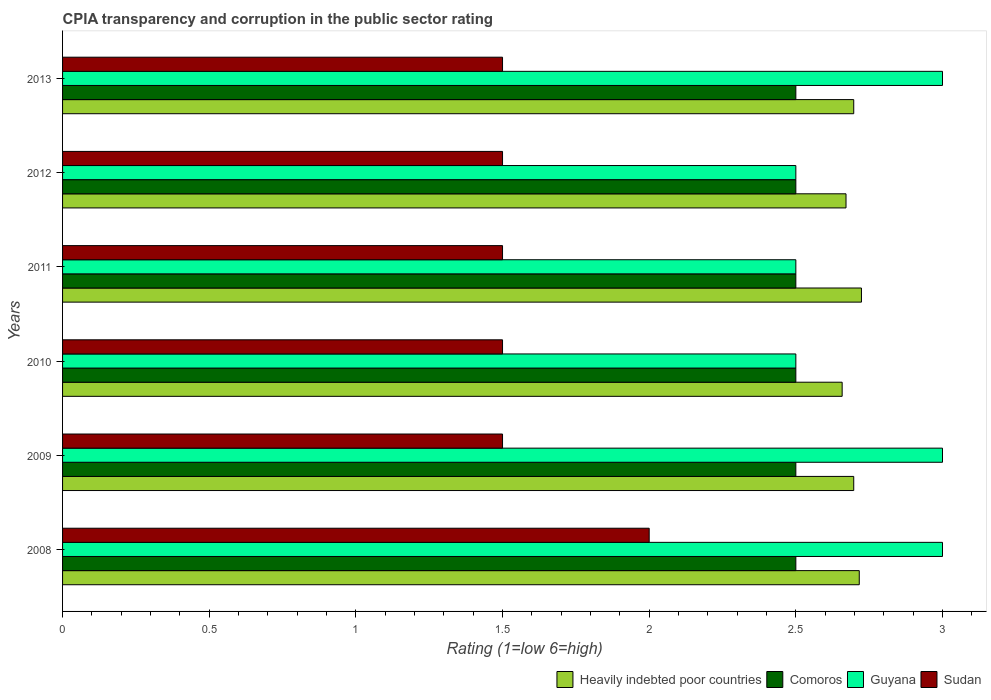How many different coloured bars are there?
Make the answer very short. 4. Are the number of bars per tick equal to the number of legend labels?
Your response must be concise. Yes. How many bars are there on the 5th tick from the top?
Keep it short and to the point. 4. What is the label of the 2nd group of bars from the top?
Make the answer very short. 2012. In how many cases, is the number of bars for a given year not equal to the number of legend labels?
Offer a very short reply. 0. Across all years, what is the minimum CPIA rating in Comoros?
Provide a short and direct response. 2.5. In which year was the CPIA rating in Comoros minimum?
Provide a short and direct response. 2008. What is the difference between the CPIA rating in Heavily indebted poor countries in 2009 and that in 2011?
Offer a very short reply. -0.03. What is the difference between the CPIA rating in Sudan in 2008 and the CPIA rating in Heavily indebted poor countries in 2013?
Offer a terse response. -0.7. In how many years, is the CPIA rating in Comoros greater than 1.8 ?
Provide a short and direct response. 6. What is the difference between the highest and the second highest CPIA rating in Heavily indebted poor countries?
Make the answer very short. 0.01. In how many years, is the CPIA rating in Heavily indebted poor countries greater than the average CPIA rating in Heavily indebted poor countries taken over all years?
Provide a short and direct response. 4. What does the 1st bar from the top in 2013 represents?
Provide a succinct answer. Sudan. What does the 2nd bar from the bottom in 2010 represents?
Make the answer very short. Comoros. Is it the case that in every year, the sum of the CPIA rating in Sudan and CPIA rating in Heavily indebted poor countries is greater than the CPIA rating in Comoros?
Provide a succinct answer. Yes. Are all the bars in the graph horizontal?
Give a very brief answer. Yes. How many years are there in the graph?
Provide a short and direct response. 6. Does the graph contain any zero values?
Provide a short and direct response. No. Does the graph contain grids?
Make the answer very short. No. Where does the legend appear in the graph?
Ensure brevity in your answer.  Bottom right. What is the title of the graph?
Offer a terse response. CPIA transparency and corruption in the public sector rating. Does "East Asia (developing only)" appear as one of the legend labels in the graph?
Your answer should be compact. No. What is the label or title of the X-axis?
Ensure brevity in your answer.  Rating (1=low 6=high). What is the Rating (1=low 6=high) of Heavily indebted poor countries in 2008?
Your response must be concise. 2.72. What is the Rating (1=low 6=high) in Heavily indebted poor countries in 2009?
Provide a short and direct response. 2.7. What is the Rating (1=low 6=high) of Comoros in 2009?
Offer a very short reply. 2.5. What is the Rating (1=low 6=high) of Guyana in 2009?
Your answer should be compact. 3. What is the Rating (1=low 6=high) in Heavily indebted poor countries in 2010?
Ensure brevity in your answer.  2.66. What is the Rating (1=low 6=high) of Comoros in 2010?
Provide a short and direct response. 2.5. What is the Rating (1=low 6=high) of Guyana in 2010?
Offer a terse response. 2.5. What is the Rating (1=low 6=high) in Sudan in 2010?
Give a very brief answer. 1.5. What is the Rating (1=low 6=high) of Heavily indebted poor countries in 2011?
Ensure brevity in your answer.  2.72. What is the Rating (1=low 6=high) in Guyana in 2011?
Give a very brief answer. 2.5. What is the Rating (1=low 6=high) in Sudan in 2011?
Your response must be concise. 1.5. What is the Rating (1=low 6=high) in Heavily indebted poor countries in 2012?
Offer a terse response. 2.67. What is the Rating (1=low 6=high) of Comoros in 2012?
Ensure brevity in your answer.  2.5. What is the Rating (1=low 6=high) of Heavily indebted poor countries in 2013?
Keep it short and to the point. 2.7. What is the Rating (1=low 6=high) of Guyana in 2013?
Provide a short and direct response. 3. What is the Rating (1=low 6=high) in Sudan in 2013?
Your answer should be very brief. 1.5. Across all years, what is the maximum Rating (1=low 6=high) in Heavily indebted poor countries?
Ensure brevity in your answer.  2.72. Across all years, what is the maximum Rating (1=low 6=high) of Comoros?
Offer a terse response. 2.5. Across all years, what is the minimum Rating (1=low 6=high) of Heavily indebted poor countries?
Provide a short and direct response. 2.66. Across all years, what is the minimum Rating (1=low 6=high) of Sudan?
Your response must be concise. 1.5. What is the total Rating (1=low 6=high) of Heavily indebted poor countries in the graph?
Your answer should be compact. 16.16. What is the total Rating (1=low 6=high) in Guyana in the graph?
Provide a succinct answer. 16.5. What is the total Rating (1=low 6=high) of Sudan in the graph?
Offer a terse response. 9.5. What is the difference between the Rating (1=low 6=high) in Heavily indebted poor countries in 2008 and that in 2009?
Your answer should be compact. 0.02. What is the difference between the Rating (1=low 6=high) of Comoros in 2008 and that in 2009?
Your answer should be very brief. 0. What is the difference between the Rating (1=low 6=high) in Guyana in 2008 and that in 2009?
Your answer should be very brief. 0. What is the difference between the Rating (1=low 6=high) in Heavily indebted poor countries in 2008 and that in 2010?
Provide a short and direct response. 0.06. What is the difference between the Rating (1=low 6=high) of Comoros in 2008 and that in 2010?
Your answer should be very brief. 0. What is the difference between the Rating (1=low 6=high) in Guyana in 2008 and that in 2010?
Your answer should be compact. 0.5. What is the difference between the Rating (1=low 6=high) in Heavily indebted poor countries in 2008 and that in 2011?
Provide a succinct answer. -0.01. What is the difference between the Rating (1=low 6=high) in Comoros in 2008 and that in 2011?
Make the answer very short. 0. What is the difference between the Rating (1=low 6=high) of Guyana in 2008 and that in 2011?
Provide a short and direct response. 0.5. What is the difference between the Rating (1=low 6=high) of Heavily indebted poor countries in 2008 and that in 2012?
Offer a very short reply. 0.05. What is the difference between the Rating (1=low 6=high) in Comoros in 2008 and that in 2012?
Offer a very short reply. 0. What is the difference between the Rating (1=low 6=high) of Guyana in 2008 and that in 2012?
Provide a succinct answer. 0.5. What is the difference between the Rating (1=low 6=high) of Heavily indebted poor countries in 2008 and that in 2013?
Make the answer very short. 0.02. What is the difference between the Rating (1=low 6=high) of Guyana in 2008 and that in 2013?
Give a very brief answer. 0. What is the difference between the Rating (1=low 6=high) in Sudan in 2008 and that in 2013?
Offer a very short reply. 0.5. What is the difference between the Rating (1=low 6=high) of Heavily indebted poor countries in 2009 and that in 2010?
Provide a succinct answer. 0.04. What is the difference between the Rating (1=low 6=high) in Heavily indebted poor countries in 2009 and that in 2011?
Offer a terse response. -0.03. What is the difference between the Rating (1=low 6=high) in Heavily indebted poor countries in 2009 and that in 2012?
Provide a succinct answer. 0.03. What is the difference between the Rating (1=low 6=high) in Guyana in 2009 and that in 2013?
Make the answer very short. 0. What is the difference between the Rating (1=low 6=high) of Heavily indebted poor countries in 2010 and that in 2011?
Your answer should be very brief. -0.07. What is the difference between the Rating (1=low 6=high) in Sudan in 2010 and that in 2011?
Your answer should be compact. 0. What is the difference between the Rating (1=low 6=high) in Heavily indebted poor countries in 2010 and that in 2012?
Provide a short and direct response. -0.01. What is the difference between the Rating (1=low 6=high) of Comoros in 2010 and that in 2012?
Your answer should be compact. 0. What is the difference between the Rating (1=low 6=high) in Guyana in 2010 and that in 2012?
Provide a short and direct response. 0. What is the difference between the Rating (1=low 6=high) of Heavily indebted poor countries in 2010 and that in 2013?
Make the answer very short. -0.04. What is the difference between the Rating (1=low 6=high) of Sudan in 2010 and that in 2013?
Keep it short and to the point. 0. What is the difference between the Rating (1=low 6=high) in Heavily indebted poor countries in 2011 and that in 2012?
Your answer should be very brief. 0.05. What is the difference between the Rating (1=low 6=high) of Guyana in 2011 and that in 2012?
Keep it short and to the point. 0. What is the difference between the Rating (1=low 6=high) of Heavily indebted poor countries in 2011 and that in 2013?
Give a very brief answer. 0.03. What is the difference between the Rating (1=low 6=high) of Heavily indebted poor countries in 2012 and that in 2013?
Keep it short and to the point. -0.03. What is the difference between the Rating (1=low 6=high) in Sudan in 2012 and that in 2013?
Give a very brief answer. 0. What is the difference between the Rating (1=low 6=high) of Heavily indebted poor countries in 2008 and the Rating (1=low 6=high) of Comoros in 2009?
Your response must be concise. 0.22. What is the difference between the Rating (1=low 6=high) in Heavily indebted poor countries in 2008 and the Rating (1=low 6=high) in Guyana in 2009?
Ensure brevity in your answer.  -0.28. What is the difference between the Rating (1=low 6=high) in Heavily indebted poor countries in 2008 and the Rating (1=low 6=high) in Sudan in 2009?
Give a very brief answer. 1.22. What is the difference between the Rating (1=low 6=high) in Comoros in 2008 and the Rating (1=low 6=high) in Guyana in 2009?
Keep it short and to the point. -0.5. What is the difference between the Rating (1=low 6=high) in Comoros in 2008 and the Rating (1=low 6=high) in Sudan in 2009?
Make the answer very short. 1. What is the difference between the Rating (1=low 6=high) of Heavily indebted poor countries in 2008 and the Rating (1=low 6=high) of Comoros in 2010?
Your answer should be compact. 0.22. What is the difference between the Rating (1=low 6=high) in Heavily indebted poor countries in 2008 and the Rating (1=low 6=high) in Guyana in 2010?
Your answer should be compact. 0.22. What is the difference between the Rating (1=low 6=high) in Heavily indebted poor countries in 2008 and the Rating (1=low 6=high) in Sudan in 2010?
Your answer should be compact. 1.22. What is the difference between the Rating (1=low 6=high) of Comoros in 2008 and the Rating (1=low 6=high) of Guyana in 2010?
Ensure brevity in your answer.  0. What is the difference between the Rating (1=low 6=high) in Comoros in 2008 and the Rating (1=low 6=high) in Sudan in 2010?
Ensure brevity in your answer.  1. What is the difference between the Rating (1=low 6=high) in Guyana in 2008 and the Rating (1=low 6=high) in Sudan in 2010?
Provide a short and direct response. 1.5. What is the difference between the Rating (1=low 6=high) of Heavily indebted poor countries in 2008 and the Rating (1=low 6=high) of Comoros in 2011?
Offer a terse response. 0.22. What is the difference between the Rating (1=low 6=high) in Heavily indebted poor countries in 2008 and the Rating (1=low 6=high) in Guyana in 2011?
Your answer should be compact. 0.22. What is the difference between the Rating (1=low 6=high) of Heavily indebted poor countries in 2008 and the Rating (1=low 6=high) of Sudan in 2011?
Provide a succinct answer. 1.22. What is the difference between the Rating (1=low 6=high) of Heavily indebted poor countries in 2008 and the Rating (1=low 6=high) of Comoros in 2012?
Your response must be concise. 0.22. What is the difference between the Rating (1=low 6=high) of Heavily indebted poor countries in 2008 and the Rating (1=low 6=high) of Guyana in 2012?
Offer a terse response. 0.22. What is the difference between the Rating (1=low 6=high) of Heavily indebted poor countries in 2008 and the Rating (1=low 6=high) of Sudan in 2012?
Keep it short and to the point. 1.22. What is the difference between the Rating (1=low 6=high) of Comoros in 2008 and the Rating (1=low 6=high) of Sudan in 2012?
Offer a terse response. 1. What is the difference between the Rating (1=low 6=high) of Heavily indebted poor countries in 2008 and the Rating (1=low 6=high) of Comoros in 2013?
Ensure brevity in your answer.  0.22. What is the difference between the Rating (1=low 6=high) of Heavily indebted poor countries in 2008 and the Rating (1=low 6=high) of Guyana in 2013?
Give a very brief answer. -0.28. What is the difference between the Rating (1=low 6=high) of Heavily indebted poor countries in 2008 and the Rating (1=low 6=high) of Sudan in 2013?
Offer a terse response. 1.22. What is the difference between the Rating (1=low 6=high) of Comoros in 2008 and the Rating (1=low 6=high) of Guyana in 2013?
Give a very brief answer. -0.5. What is the difference between the Rating (1=low 6=high) of Comoros in 2008 and the Rating (1=low 6=high) of Sudan in 2013?
Give a very brief answer. 1. What is the difference between the Rating (1=low 6=high) in Heavily indebted poor countries in 2009 and the Rating (1=low 6=high) in Comoros in 2010?
Offer a very short reply. 0.2. What is the difference between the Rating (1=low 6=high) of Heavily indebted poor countries in 2009 and the Rating (1=low 6=high) of Guyana in 2010?
Provide a short and direct response. 0.2. What is the difference between the Rating (1=low 6=high) in Heavily indebted poor countries in 2009 and the Rating (1=low 6=high) in Sudan in 2010?
Provide a short and direct response. 1.2. What is the difference between the Rating (1=low 6=high) in Comoros in 2009 and the Rating (1=low 6=high) in Guyana in 2010?
Offer a very short reply. 0. What is the difference between the Rating (1=low 6=high) in Comoros in 2009 and the Rating (1=low 6=high) in Sudan in 2010?
Make the answer very short. 1. What is the difference between the Rating (1=low 6=high) of Guyana in 2009 and the Rating (1=low 6=high) of Sudan in 2010?
Your answer should be very brief. 1.5. What is the difference between the Rating (1=low 6=high) of Heavily indebted poor countries in 2009 and the Rating (1=low 6=high) of Comoros in 2011?
Give a very brief answer. 0.2. What is the difference between the Rating (1=low 6=high) in Heavily indebted poor countries in 2009 and the Rating (1=low 6=high) in Guyana in 2011?
Keep it short and to the point. 0.2. What is the difference between the Rating (1=low 6=high) in Heavily indebted poor countries in 2009 and the Rating (1=low 6=high) in Sudan in 2011?
Provide a short and direct response. 1.2. What is the difference between the Rating (1=low 6=high) in Comoros in 2009 and the Rating (1=low 6=high) in Guyana in 2011?
Offer a terse response. 0. What is the difference between the Rating (1=low 6=high) in Heavily indebted poor countries in 2009 and the Rating (1=low 6=high) in Comoros in 2012?
Provide a short and direct response. 0.2. What is the difference between the Rating (1=low 6=high) of Heavily indebted poor countries in 2009 and the Rating (1=low 6=high) of Guyana in 2012?
Make the answer very short. 0.2. What is the difference between the Rating (1=low 6=high) of Heavily indebted poor countries in 2009 and the Rating (1=low 6=high) of Sudan in 2012?
Your answer should be compact. 1.2. What is the difference between the Rating (1=low 6=high) in Comoros in 2009 and the Rating (1=low 6=high) in Sudan in 2012?
Give a very brief answer. 1. What is the difference between the Rating (1=low 6=high) of Heavily indebted poor countries in 2009 and the Rating (1=low 6=high) of Comoros in 2013?
Offer a very short reply. 0.2. What is the difference between the Rating (1=low 6=high) of Heavily indebted poor countries in 2009 and the Rating (1=low 6=high) of Guyana in 2013?
Provide a short and direct response. -0.3. What is the difference between the Rating (1=low 6=high) of Heavily indebted poor countries in 2009 and the Rating (1=low 6=high) of Sudan in 2013?
Make the answer very short. 1.2. What is the difference between the Rating (1=low 6=high) of Comoros in 2009 and the Rating (1=low 6=high) of Sudan in 2013?
Provide a succinct answer. 1. What is the difference between the Rating (1=low 6=high) of Guyana in 2009 and the Rating (1=low 6=high) of Sudan in 2013?
Your answer should be compact. 1.5. What is the difference between the Rating (1=low 6=high) in Heavily indebted poor countries in 2010 and the Rating (1=low 6=high) in Comoros in 2011?
Offer a very short reply. 0.16. What is the difference between the Rating (1=low 6=high) in Heavily indebted poor countries in 2010 and the Rating (1=low 6=high) in Guyana in 2011?
Ensure brevity in your answer.  0.16. What is the difference between the Rating (1=low 6=high) in Heavily indebted poor countries in 2010 and the Rating (1=low 6=high) in Sudan in 2011?
Provide a short and direct response. 1.16. What is the difference between the Rating (1=low 6=high) of Comoros in 2010 and the Rating (1=low 6=high) of Sudan in 2011?
Provide a short and direct response. 1. What is the difference between the Rating (1=low 6=high) in Guyana in 2010 and the Rating (1=low 6=high) in Sudan in 2011?
Ensure brevity in your answer.  1. What is the difference between the Rating (1=low 6=high) of Heavily indebted poor countries in 2010 and the Rating (1=low 6=high) of Comoros in 2012?
Keep it short and to the point. 0.16. What is the difference between the Rating (1=low 6=high) in Heavily indebted poor countries in 2010 and the Rating (1=low 6=high) in Guyana in 2012?
Ensure brevity in your answer.  0.16. What is the difference between the Rating (1=low 6=high) of Heavily indebted poor countries in 2010 and the Rating (1=low 6=high) of Sudan in 2012?
Give a very brief answer. 1.16. What is the difference between the Rating (1=low 6=high) in Heavily indebted poor countries in 2010 and the Rating (1=low 6=high) in Comoros in 2013?
Offer a terse response. 0.16. What is the difference between the Rating (1=low 6=high) in Heavily indebted poor countries in 2010 and the Rating (1=low 6=high) in Guyana in 2013?
Make the answer very short. -0.34. What is the difference between the Rating (1=low 6=high) in Heavily indebted poor countries in 2010 and the Rating (1=low 6=high) in Sudan in 2013?
Ensure brevity in your answer.  1.16. What is the difference between the Rating (1=low 6=high) of Comoros in 2010 and the Rating (1=low 6=high) of Guyana in 2013?
Offer a very short reply. -0.5. What is the difference between the Rating (1=low 6=high) in Comoros in 2010 and the Rating (1=low 6=high) in Sudan in 2013?
Make the answer very short. 1. What is the difference between the Rating (1=low 6=high) of Guyana in 2010 and the Rating (1=low 6=high) of Sudan in 2013?
Your answer should be compact. 1. What is the difference between the Rating (1=low 6=high) of Heavily indebted poor countries in 2011 and the Rating (1=low 6=high) of Comoros in 2012?
Give a very brief answer. 0.22. What is the difference between the Rating (1=low 6=high) of Heavily indebted poor countries in 2011 and the Rating (1=low 6=high) of Guyana in 2012?
Provide a succinct answer. 0.22. What is the difference between the Rating (1=low 6=high) of Heavily indebted poor countries in 2011 and the Rating (1=low 6=high) of Sudan in 2012?
Your answer should be very brief. 1.22. What is the difference between the Rating (1=low 6=high) in Guyana in 2011 and the Rating (1=low 6=high) in Sudan in 2012?
Offer a terse response. 1. What is the difference between the Rating (1=low 6=high) of Heavily indebted poor countries in 2011 and the Rating (1=low 6=high) of Comoros in 2013?
Provide a succinct answer. 0.22. What is the difference between the Rating (1=low 6=high) of Heavily indebted poor countries in 2011 and the Rating (1=low 6=high) of Guyana in 2013?
Ensure brevity in your answer.  -0.28. What is the difference between the Rating (1=low 6=high) of Heavily indebted poor countries in 2011 and the Rating (1=low 6=high) of Sudan in 2013?
Keep it short and to the point. 1.22. What is the difference between the Rating (1=low 6=high) of Comoros in 2011 and the Rating (1=low 6=high) of Guyana in 2013?
Your answer should be compact. -0.5. What is the difference between the Rating (1=low 6=high) in Guyana in 2011 and the Rating (1=low 6=high) in Sudan in 2013?
Keep it short and to the point. 1. What is the difference between the Rating (1=low 6=high) of Heavily indebted poor countries in 2012 and the Rating (1=low 6=high) of Comoros in 2013?
Provide a short and direct response. 0.17. What is the difference between the Rating (1=low 6=high) in Heavily indebted poor countries in 2012 and the Rating (1=low 6=high) in Guyana in 2013?
Your response must be concise. -0.33. What is the difference between the Rating (1=low 6=high) in Heavily indebted poor countries in 2012 and the Rating (1=low 6=high) in Sudan in 2013?
Make the answer very short. 1.17. What is the difference between the Rating (1=low 6=high) of Comoros in 2012 and the Rating (1=low 6=high) of Guyana in 2013?
Give a very brief answer. -0.5. What is the difference between the Rating (1=low 6=high) of Guyana in 2012 and the Rating (1=low 6=high) of Sudan in 2013?
Provide a short and direct response. 1. What is the average Rating (1=low 6=high) in Heavily indebted poor countries per year?
Provide a short and direct response. 2.69. What is the average Rating (1=low 6=high) in Comoros per year?
Provide a short and direct response. 2.5. What is the average Rating (1=low 6=high) in Guyana per year?
Your response must be concise. 2.75. What is the average Rating (1=low 6=high) of Sudan per year?
Provide a short and direct response. 1.58. In the year 2008, what is the difference between the Rating (1=low 6=high) in Heavily indebted poor countries and Rating (1=low 6=high) in Comoros?
Provide a succinct answer. 0.22. In the year 2008, what is the difference between the Rating (1=low 6=high) in Heavily indebted poor countries and Rating (1=low 6=high) in Guyana?
Make the answer very short. -0.28. In the year 2008, what is the difference between the Rating (1=low 6=high) in Heavily indebted poor countries and Rating (1=low 6=high) in Sudan?
Offer a very short reply. 0.72. In the year 2008, what is the difference between the Rating (1=low 6=high) of Comoros and Rating (1=low 6=high) of Sudan?
Your answer should be compact. 0.5. In the year 2008, what is the difference between the Rating (1=low 6=high) of Guyana and Rating (1=low 6=high) of Sudan?
Your answer should be compact. 1. In the year 2009, what is the difference between the Rating (1=low 6=high) in Heavily indebted poor countries and Rating (1=low 6=high) in Comoros?
Your response must be concise. 0.2. In the year 2009, what is the difference between the Rating (1=low 6=high) in Heavily indebted poor countries and Rating (1=low 6=high) in Guyana?
Make the answer very short. -0.3. In the year 2009, what is the difference between the Rating (1=low 6=high) of Heavily indebted poor countries and Rating (1=low 6=high) of Sudan?
Your answer should be very brief. 1.2. In the year 2009, what is the difference between the Rating (1=low 6=high) in Comoros and Rating (1=low 6=high) in Sudan?
Ensure brevity in your answer.  1. In the year 2010, what is the difference between the Rating (1=low 6=high) of Heavily indebted poor countries and Rating (1=low 6=high) of Comoros?
Make the answer very short. 0.16. In the year 2010, what is the difference between the Rating (1=low 6=high) of Heavily indebted poor countries and Rating (1=low 6=high) of Guyana?
Offer a terse response. 0.16. In the year 2010, what is the difference between the Rating (1=low 6=high) in Heavily indebted poor countries and Rating (1=low 6=high) in Sudan?
Your response must be concise. 1.16. In the year 2010, what is the difference between the Rating (1=low 6=high) of Guyana and Rating (1=low 6=high) of Sudan?
Ensure brevity in your answer.  1. In the year 2011, what is the difference between the Rating (1=low 6=high) of Heavily indebted poor countries and Rating (1=low 6=high) of Comoros?
Ensure brevity in your answer.  0.22. In the year 2011, what is the difference between the Rating (1=low 6=high) of Heavily indebted poor countries and Rating (1=low 6=high) of Guyana?
Give a very brief answer. 0.22. In the year 2011, what is the difference between the Rating (1=low 6=high) of Heavily indebted poor countries and Rating (1=low 6=high) of Sudan?
Provide a short and direct response. 1.22. In the year 2011, what is the difference between the Rating (1=low 6=high) of Comoros and Rating (1=low 6=high) of Guyana?
Provide a short and direct response. 0. In the year 2011, what is the difference between the Rating (1=low 6=high) of Guyana and Rating (1=low 6=high) of Sudan?
Keep it short and to the point. 1. In the year 2012, what is the difference between the Rating (1=low 6=high) of Heavily indebted poor countries and Rating (1=low 6=high) of Comoros?
Keep it short and to the point. 0.17. In the year 2012, what is the difference between the Rating (1=low 6=high) of Heavily indebted poor countries and Rating (1=low 6=high) of Guyana?
Keep it short and to the point. 0.17. In the year 2012, what is the difference between the Rating (1=low 6=high) of Heavily indebted poor countries and Rating (1=low 6=high) of Sudan?
Offer a very short reply. 1.17. In the year 2012, what is the difference between the Rating (1=low 6=high) in Comoros and Rating (1=low 6=high) in Guyana?
Make the answer very short. 0. In the year 2013, what is the difference between the Rating (1=low 6=high) of Heavily indebted poor countries and Rating (1=low 6=high) of Comoros?
Keep it short and to the point. 0.2. In the year 2013, what is the difference between the Rating (1=low 6=high) of Heavily indebted poor countries and Rating (1=low 6=high) of Guyana?
Provide a succinct answer. -0.3. In the year 2013, what is the difference between the Rating (1=low 6=high) of Heavily indebted poor countries and Rating (1=low 6=high) of Sudan?
Ensure brevity in your answer.  1.2. What is the ratio of the Rating (1=low 6=high) in Heavily indebted poor countries in 2008 to that in 2009?
Provide a short and direct response. 1.01. What is the ratio of the Rating (1=low 6=high) of Comoros in 2008 to that in 2009?
Your response must be concise. 1. What is the ratio of the Rating (1=low 6=high) in Guyana in 2008 to that in 2009?
Offer a very short reply. 1. What is the ratio of the Rating (1=low 6=high) in Sudan in 2008 to that in 2009?
Provide a succinct answer. 1.33. What is the ratio of the Rating (1=low 6=high) in Heavily indebted poor countries in 2008 to that in 2010?
Offer a terse response. 1.02. What is the ratio of the Rating (1=low 6=high) of Heavily indebted poor countries in 2008 to that in 2011?
Offer a terse response. 1. What is the ratio of the Rating (1=low 6=high) of Comoros in 2008 to that in 2011?
Ensure brevity in your answer.  1. What is the ratio of the Rating (1=low 6=high) of Heavily indebted poor countries in 2008 to that in 2012?
Provide a succinct answer. 1.02. What is the ratio of the Rating (1=low 6=high) in Guyana in 2008 to that in 2012?
Offer a very short reply. 1.2. What is the ratio of the Rating (1=low 6=high) in Comoros in 2008 to that in 2013?
Your answer should be very brief. 1. What is the ratio of the Rating (1=low 6=high) of Heavily indebted poor countries in 2009 to that in 2010?
Your answer should be very brief. 1.01. What is the ratio of the Rating (1=low 6=high) in Comoros in 2009 to that in 2010?
Provide a short and direct response. 1. What is the ratio of the Rating (1=low 6=high) of Heavily indebted poor countries in 2009 to that in 2011?
Provide a short and direct response. 0.99. What is the ratio of the Rating (1=low 6=high) in Comoros in 2009 to that in 2011?
Your response must be concise. 1. What is the ratio of the Rating (1=low 6=high) in Sudan in 2009 to that in 2011?
Provide a short and direct response. 1. What is the ratio of the Rating (1=low 6=high) in Heavily indebted poor countries in 2009 to that in 2012?
Provide a short and direct response. 1.01. What is the ratio of the Rating (1=low 6=high) in Comoros in 2009 to that in 2012?
Your answer should be compact. 1. What is the ratio of the Rating (1=low 6=high) of Guyana in 2009 to that in 2012?
Make the answer very short. 1.2. What is the ratio of the Rating (1=low 6=high) of Sudan in 2009 to that in 2012?
Provide a succinct answer. 1. What is the ratio of the Rating (1=low 6=high) of Comoros in 2009 to that in 2013?
Provide a short and direct response. 1. What is the ratio of the Rating (1=low 6=high) of Heavily indebted poor countries in 2010 to that in 2011?
Provide a short and direct response. 0.98. What is the ratio of the Rating (1=low 6=high) in Comoros in 2010 to that in 2011?
Your answer should be compact. 1. What is the ratio of the Rating (1=low 6=high) of Guyana in 2010 to that in 2011?
Your response must be concise. 1. What is the ratio of the Rating (1=low 6=high) of Sudan in 2010 to that in 2011?
Provide a short and direct response. 1. What is the ratio of the Rating (1=low 6=high) in Heavily indebted poor countries in 2010 to that in 2012?
Keep it short and to the point. 1. What is the ratio of the Rating (1=low 6=high) of Heavily indebted poor countries in 2010 to that in 2013?
Give a very brief answer. 0.99. What is the ratio of the Rating (1=low 6=high) in Comoros in 2010 to that in 2013?
Keep it short and to the point. 1. What is the ratio of the Rating (1=low 6=high) of Guyana in 2010 to that in 2013?
Your answer should be compact. 0.83. What is the ratio of the Rating (1=low 6=high) in Heavily indebted poor countries in 2011 to that in 2012?
Keep it short and to the point. 1.02. What is the ratio of the Rating (1=low 6=high) in Comoros in 2011 to that in 2012?
Offer a very short reply. 1. What is the ratio of the Rating (1=low 6=high) of Heavily indebted poor countries in 2011 to that in 2013?
Your response must be concise. 1.01. What is the ratio of the Rating (1=low 6=high) in Comoros in 2011 to that in 2013?
Provide a short and direct response. 1. What is the ratio of the Rating (1=low 6=high) in Guyana in 2011 to that in 2013?
Your answer should be very brief. 0.83. What is the ratio of the Rating (1=low 6=high) in Heavily indebted poor countries in 2012 to that in 2013?
Offer a terse response. 0.99. What is the ratio of the Rating (1=low 6=high) of Comoros in 2012 to that in 2013?
Give a very brief answer. 1. What is the ratio of the Rating (1=low 6=high) in Guyana in 2012 to that in 2013?
Your response must be concise. 0.83. What is the difference between the highest and the second highest Rating (1=low 6=high) in Heavily indebted poor countries?
Ensure brevity in your answer.  0.01. What is the difference between the highest and the second highest Rating (1=low 6=high) of Guyana?
Your answer should be very brief. 0. What is the difference between the highest and the lowest Rating (1=low 6=high) of Heavily indebted poor countries?
Give a very brief answer. 0.07. What is the difference between the highest and the lowest Rating (1=low 6=high) in Comoros?
Your answer should be compact. 0. What is the difference between the highest and the lowest Rating (1=low 6=high) of Guyana?
Ensure brevity in your answer.  0.5. 